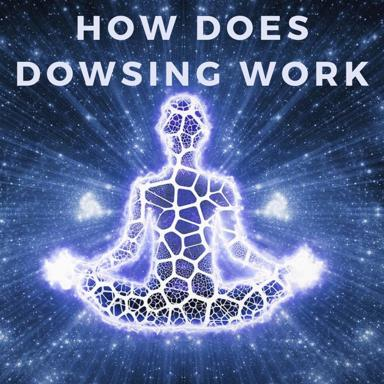Can you describe the man in the image? The man depicted in the image is seated in the lotus position, suggesting practices related to meditation or yoga. This pose, coupled with his illuminated, star-like background and body resembling a network of galaxies, symbolically connects him to the cosmos, possibly indicating a deeper, spiritual or metaphysical theme linked to the practice of dowsing. 